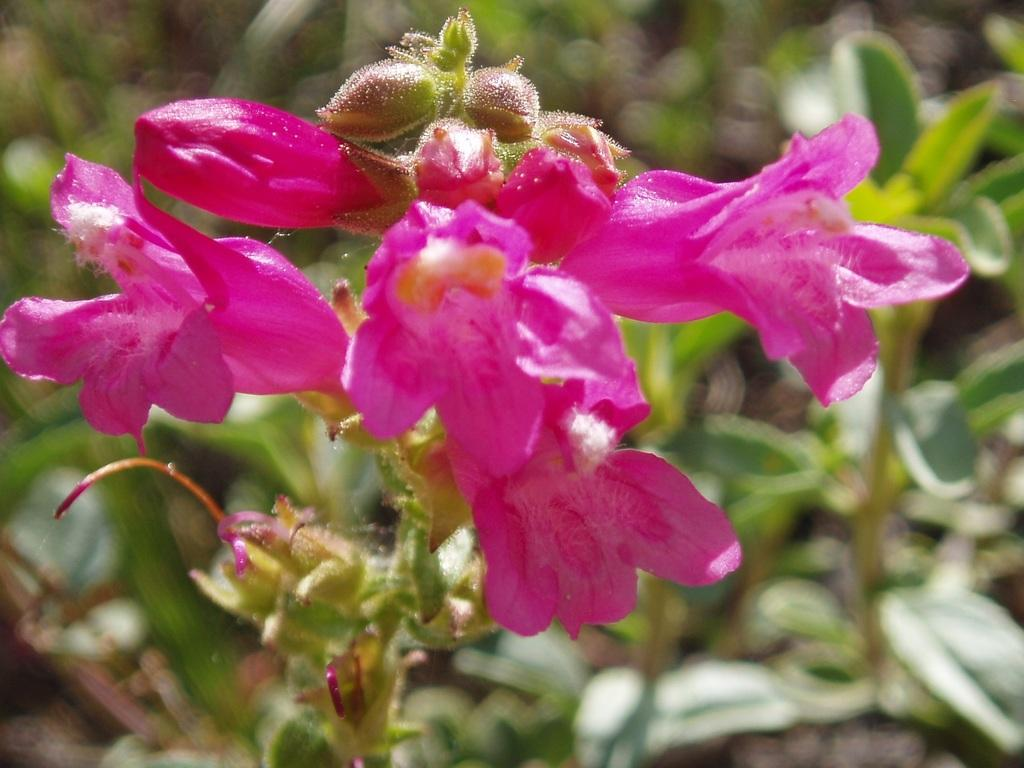What type of plant is featured in the image? The plant in the image has flowers and buds. What else can be seen in the background of the image? There are other plants and grass visible in the background. Can you describe the image quality of the background? The background has a blurred image. What type of vessel is used to water the plants in the image? There is no vessel visible in the image, so it cannot be determined what type of vessel might be used to water the plants. 